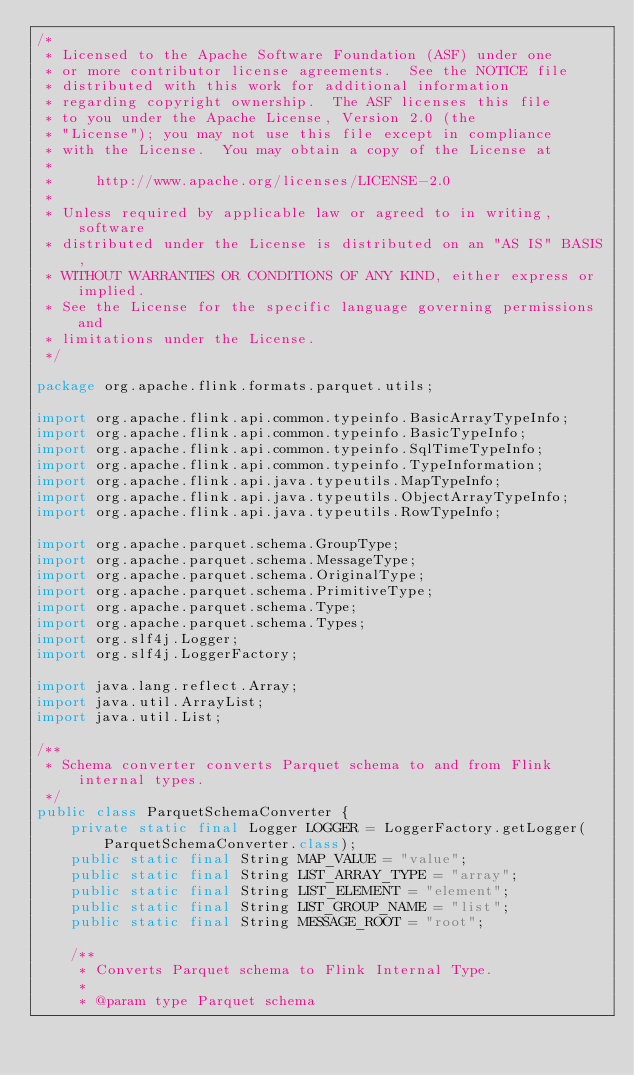<code> <loc_0><loc_0><loc_500><loc_500><_Java_>/*
 * Licensed to the Apache Software Foundation (ASF) under one
 * or more contributor license agreements.  See the NOTICE file
 * distributed with this work for additional information
 * regarding copyright ownership.  The ASF licenses this file
 * to you under the Apache License, Version 2.0 (the
 * "License"); you may not use this file except in compliance
 * with the License.  You may obtain a copy of the License at
 *
 *     http://www.apache.org/licenses/LICENSE-2.0
 *
 * Unless required by applicable law or agreed to in writing, software
 * distributed under the License is distributed on an "AS IS" BASIS,
 * WITHOUT WARRANTIES OR CONDITIONS OF ANY KIND, either express or implied.
 * See the License for the specific language governing permissions and
 * limitations under the License.
 */

package org.apache.flink.formats.parquet.utils;

import org.apache.flink.api.common.typeinfo.BasicArrayTypeInfo;
import org.apache.flink.api.common.typeinfo.BasicTypeInfo;
import org.apache.flink.api.common.typeinfo.SqlTimeTypeInfo;
import org.apache.flink.api.common.typeinfo.TypeInformation;
import org.apache.flink.api.java.typeutils.MapTypeInfo;
import org.apache.flink.api.java.typeutils.ObjectArrayTypeInfo;
import org.apache.flink.api.java.typeutils.RowTypeInfo;

import org.apache.parquet.schema.GroupType;
import org.apache.parquet.schema.MessageType;
import org.apache.parquet.schema.OriginalType;
import org.apache.parquet.schema.PrimitiveType;
import org.apache.parquet.schema.Type;
import org.apache.parquet.schema.Types;
import org.slf4j.Logger;
import org.slf4j.LoggerFactory;

import java.lang.reflect.Array;
import java.util.ArrayList;
import java.util.List;

/**
 * Schema converter converts Parquet schema to and from Flink internal types.
 */
public class ParquetSchemaConverter {
	private static final Logger LOGGER = LoggerFactory.getLogger(ParquetSchemaConverter.class);
	public static final String MAP_VALUE = "value";
	public static final String LIST_ARRAY_TYPE = "array";
	public static final String LIST_ELEMENT = "element";
	public static final String LIST_GROUP_NAME = "list";
	public static final String MESSAGE_ROOT = "root";

	/**
	 * Converts Parquet schema to Flink Internal Type.
	 *
	 * @param type Parquet schema</code> 